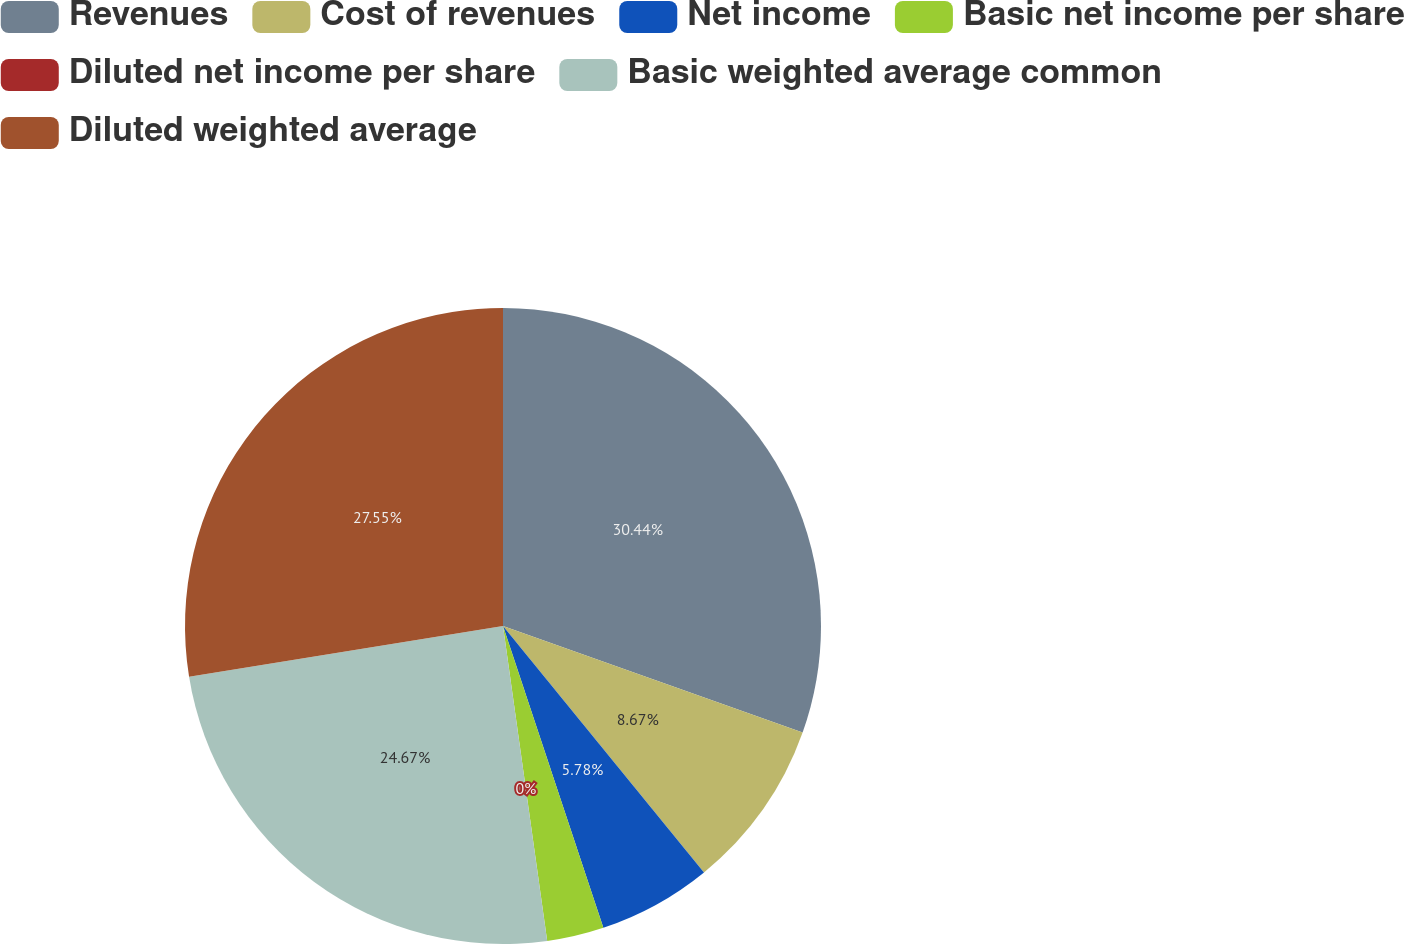Convert chart. <chart><loc_0><loc_0><loc_500><loc_500><pie_chart><fcel>Revenues<fcel>Cost of revenues<fcel>Net income<fcel>Basic net income per share<fcel>Diluted net income per share<fcel>Basic weighted average common<fcel>Diluted weighted average<nl><fcel>30.44%<fcel>8.67%<fcel>5.78%<fcel>2.89%<fcel>0.0%<fcel>24.67%<fcel>27.55%<nl></chart> 